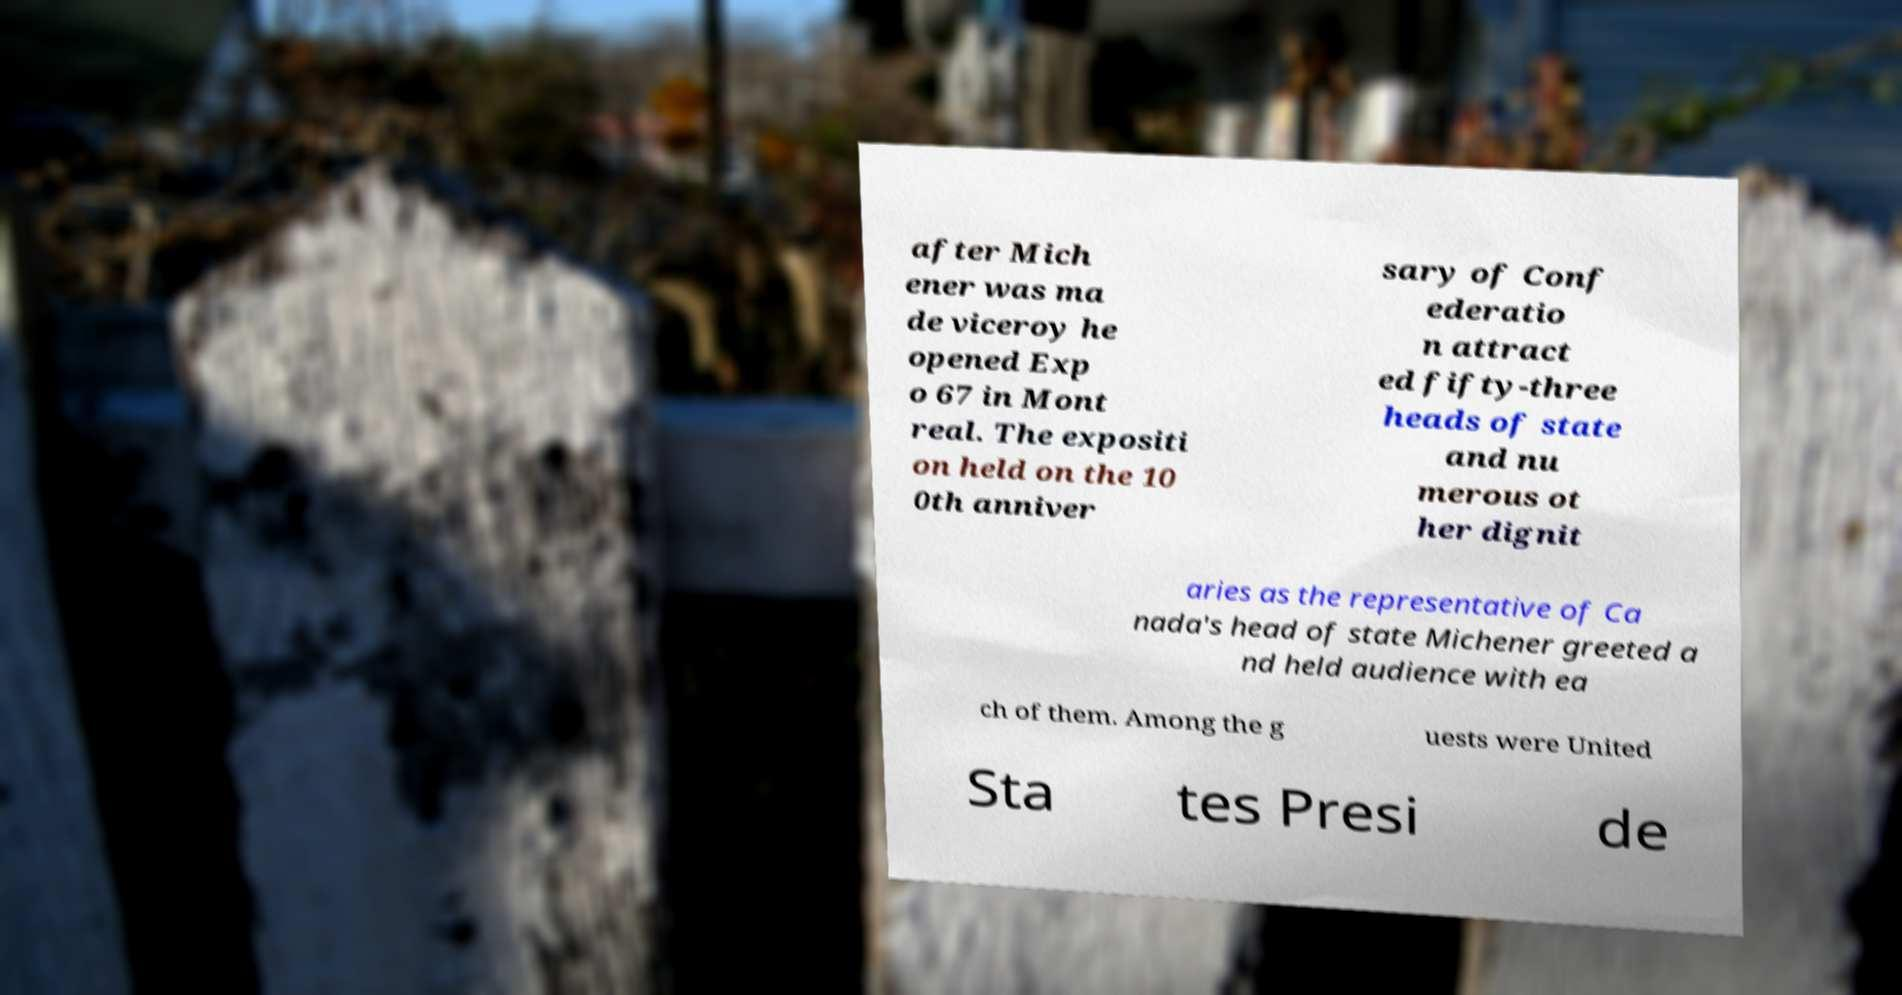What messages or text are displayed in this image? I need them in a readable, typed format. after Mich ener was ma de viceroy he opened Exp o 67 in Mont real. The expositi on held on the 10 0th anniver sary of Conf ederatio n attract ed fifty-three heads of state and nu merous ot her dignit aries as the representative of Ca nada's head of state Michener greeted a nd held audience with ea ch of them. Among the g uests were United Sta tes Presi de 